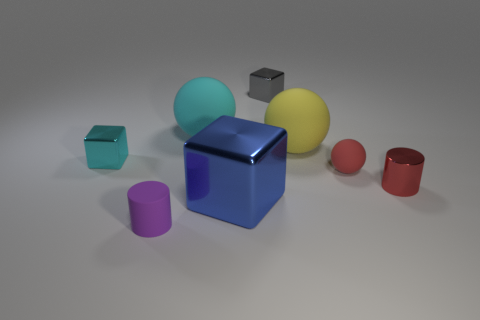Add 2 blue shiny objects. How many objects exist? 10 Subtract all big matte spheres. How many spheres are left? 1 Subtract all gray blocks. How many blocks are left? 2 Subtract 0 green spheres. How many objects are left? 8 Subtract all cylinders. How many objects are left? 6 Subtract 2 cylinders. How many cylinders are left? 0 Subtract all purple cylinders. Subtract all gray spheres. How many cylinders are left? 1 Subtract all purple balls. How many purple cylinders are left? 1 Subtract all tiny purple matte cylinders. Subtract all small cyan metal blocks. How many objects are left? 6 Add 6 metallic cylinders. How many metallic cylinders are left? 7 